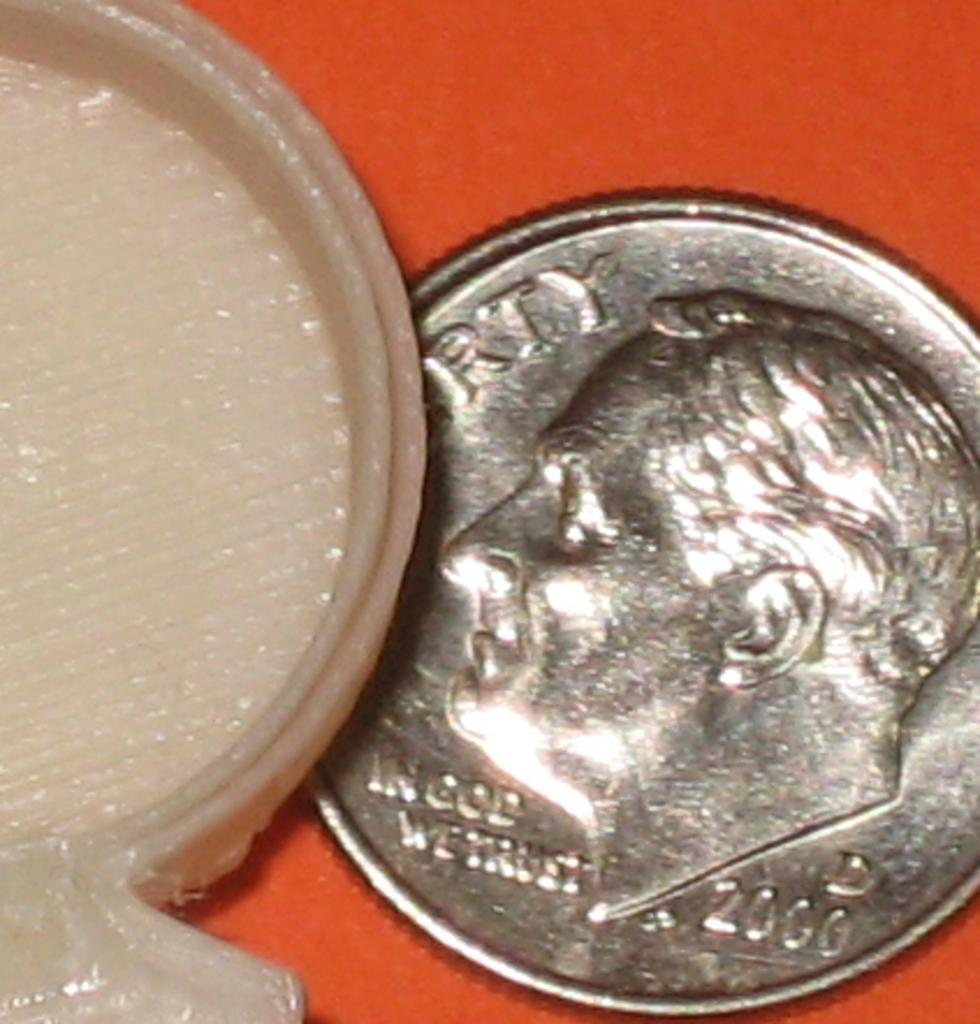<image>
Summarize the visual content of the image. A dime from 2000 that says Liberty on a red table. 